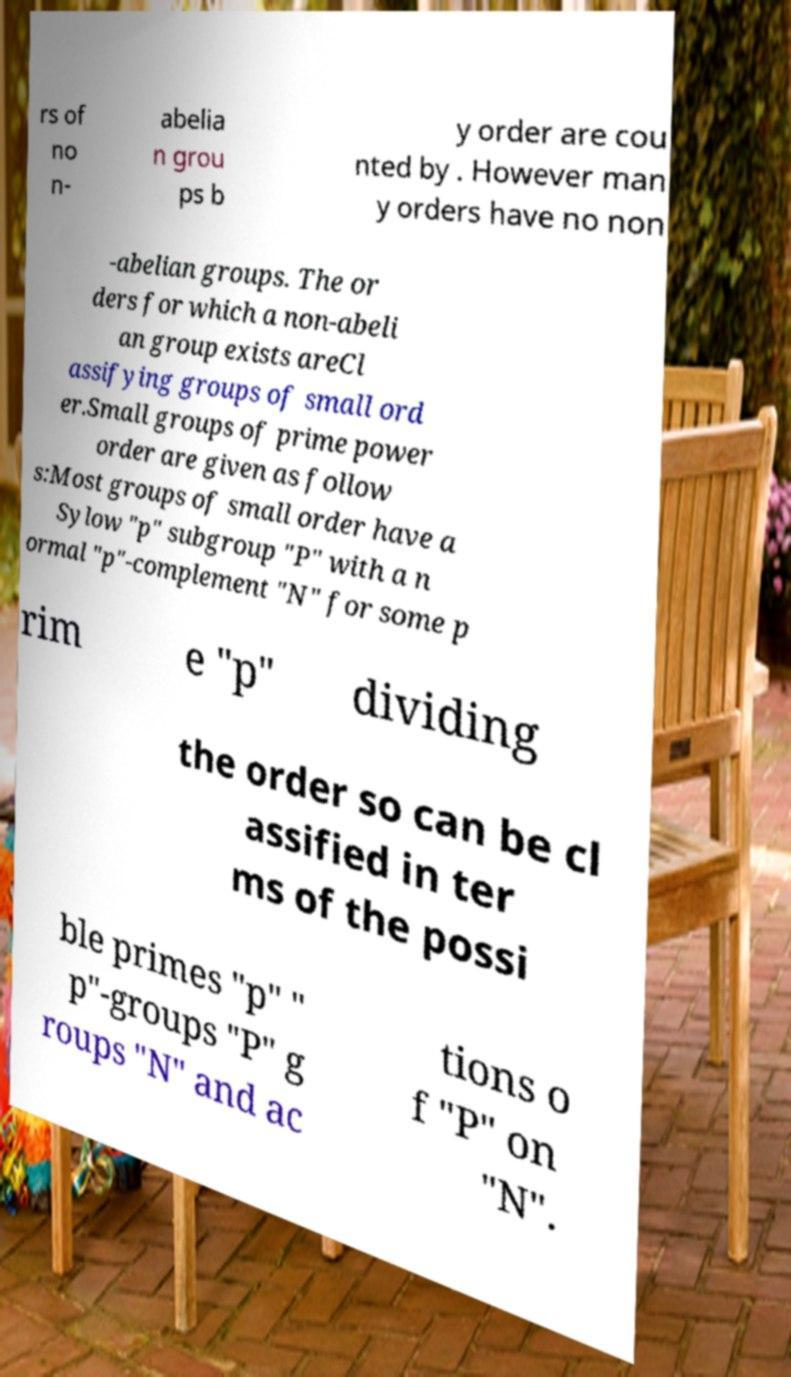Could you assist in decoding the text presented in this image and type it out clearly? rs of no n- abelia n grou ps b y order are cou nted by . However man y orders have no non -abelian groups. The or ders for which a non-abeli an group exists areCl assifying groups of small ord er.Small groups of prime power order are given as follow s:Most groups of small order have a Sylow "p" subgroup "P" with a n ormal "p"-complement "N" for some p rim e "p" dividing the order so can be cl assified in ter ms of the possi ble primes "p" " p"-groups "P" g roups "N" and ac tions o f "P" on "N". 